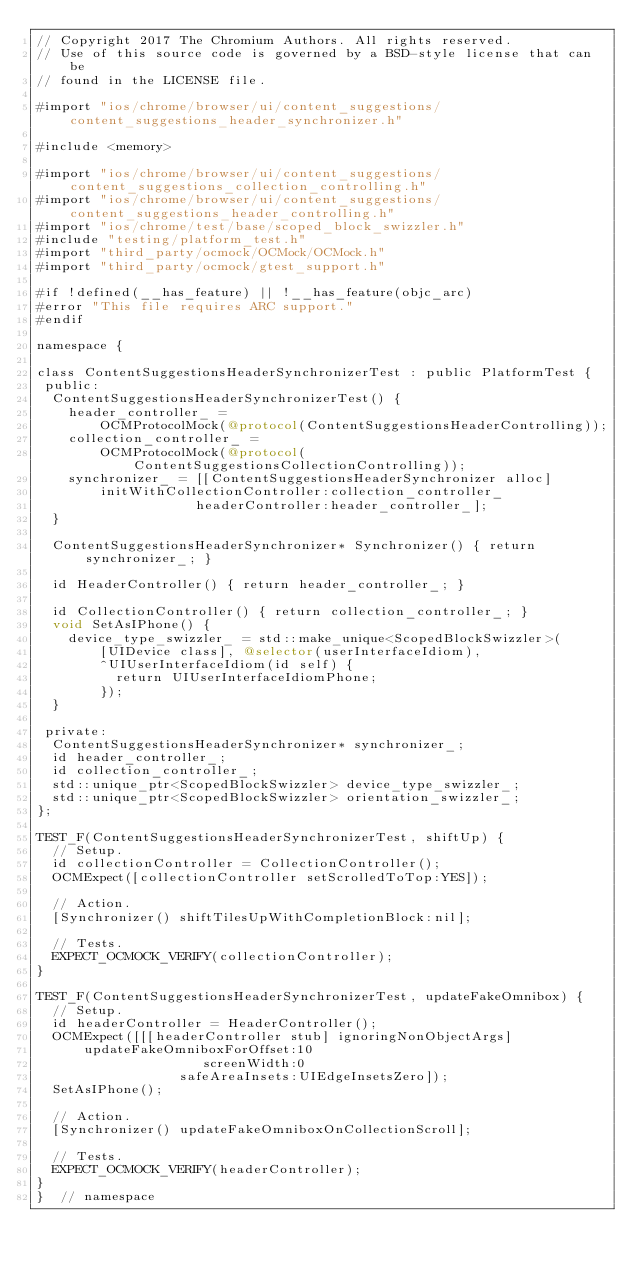<code> <loc_0><loc_0><loc_500><loc_500><_ObjectiveC_>// Copyright 2017 The Chromium Authors. All rights reserved.
// Use of this source code is governed by a BSD-style license that can be
// found in the LICENSE file.

#import "ios/chrome/browser/ui/content_suggestions/content_suggestions_header_synchronizer.h"

#include <memory>

#import "ios/chrome/browser/ui/content_suggestions/content_suggestions_collection_controlling.h"
#import "ios/chrome/browser/ui/content_suggestions/content_suggestions_header_controlling.h"
#import "ios/chrome/test/base/scoped_block_swizzler.h"
#include "testing/platform_test.h"
#import "third_party/ocmock/OCMock/OCMock.h"
#import "third_party/ocmock/gtest_support.h"

#if !defined(__has_feature) || !__has_feature(objc_arc)
#error "This file requires ARC support."
#endif

namespace {

class ContentSuggestionsHeaderSynchronizerTest : public PlatformTest {
 public:
  ContentSuggestionsHeaderSynchronizerTest() {
    header_controller_ =
        OCMProtocolMock(@protocol(ContentSuggestionsHeaderControlling));
    collection_controller_ =
        OCMProtocolMock(@protocol(ContentSuggestionsCollectionControlling));
    synchronizer_ = [[ContentSuggestionsHeaderSynchronizer alloc]
        initWithCollectionController:collection_controller_
                    headerController:header_controller_];
  }

  ContentSuggestionsHeaderSynchronizer* Synchronizer() { return synchronizer_; }

  id HeaderController() { return header_controller_; }

  id CollectionController() { return collection_controller_; }
  void SetAsIPhone() {
    device_type_swizzler_ = std::make_unique<ScopedBlockSwizzler>(
        [UIDevice class], @selector(userInterfaceIdiom),
        ^UIUserInterfaceIdiom(id self) {
          return UIUserInterfaceIdiomPhone;
        });
  }

 private:
  ContentSuggestionsHeaderSynchronizer* synchronizer_;
  id header_controller_;
  id collection_controller_;
  std::unique_ptr<ScopedBlockSwizzler> device_type_swizzler_;
  std::unique_ptr<ScopedBlockSwizzler> orientation_swizzler_;
};

TEST_F(ContentSuggestionsHeaderSynchronizerTest, shiftUp) {
  // Setup.
  id collectionController = CollectionController();
  OCMExpect([collectionController setScrolledToTop:YES]);

  // Action.
  [Synchronizer() shiftTilesUpWithCompletionBlock:nil];

  // Tests.
  EXPECT_OCMOCK_VERIFY(collectionController);
}

TEST_F(ContentSuggestionsHeaderSynchronizerTest, updateFakeOmnibox) {
  // Setup.
  id headerController = HeaderController();
  OCMExpect([[[headerController stub] ignoringNonObjectArgs]
      updateFakeOmniboxForOffset:10
                     screenWidth:0
                  safeAreaInsets:UIEdgeInsetsZero]);
  SetAsIPhone();

  // Action.
  [Synchronizer() updateFakeOmniboxOnCollectionScroll];

  // Tests.
  EXPECT_OCMOCK_VERIFY(headerController);
}
}  // namespace
</code> 